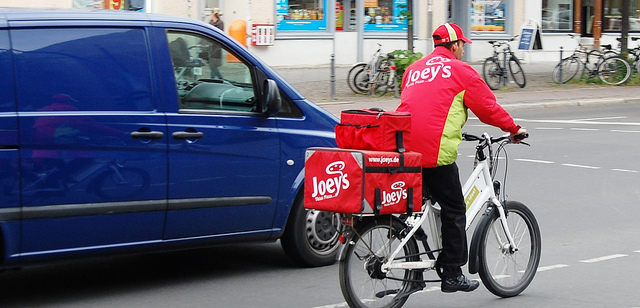Please transcribe the text in this image. Joeys joeys Joeys 